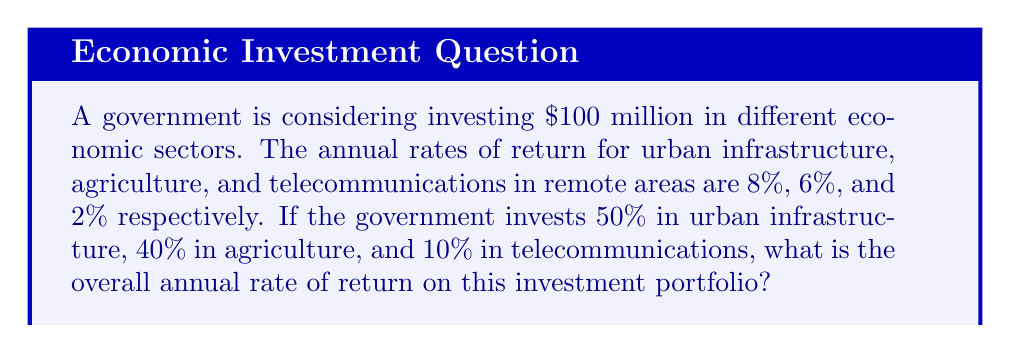Could you help me with this problem? Let's approach this step-by-step:

1) First, we need to calculate the amount invested in each sector:
   Urban infrastructure: $100 million × 50% = $50 million
   Agriculture: $100 million × 40% = $40 million
   Telecommunications: $100 million × 10% = $10 million

2) Now, we calculate the return for each sector:
   Urban infrastructure: $50 million × 8% = $4 million
   Agriculture: $40 million × 6% = $2.4 million
   Telecommunications: $10 million × 2% = $0.2 million

3) The total return is the sum of these:
   $4 million + $2.4 million + $0.2 million = $6.6 million

4) To find the overall rate of return, we divide the total return by the total investment:

   $$\text{Rate of Return} = \frac{\text{Total Return}}{\text{Total Investment}} \times 100\%$$

   $$= \frac{\$6.6 \text{ million}}{\$100 \text{ million}} \times 100\% = 0.066 \times 100\% = 6.6\%$$

Therefore, the overall annual rate of return on this investment portfolio is 6.6%.
Answer: 6.6% 